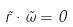<formula> <loc_0><loc_0><loc_500><loc_500>\vec { r } \cdot \vec { \omega } = 0</formula> 